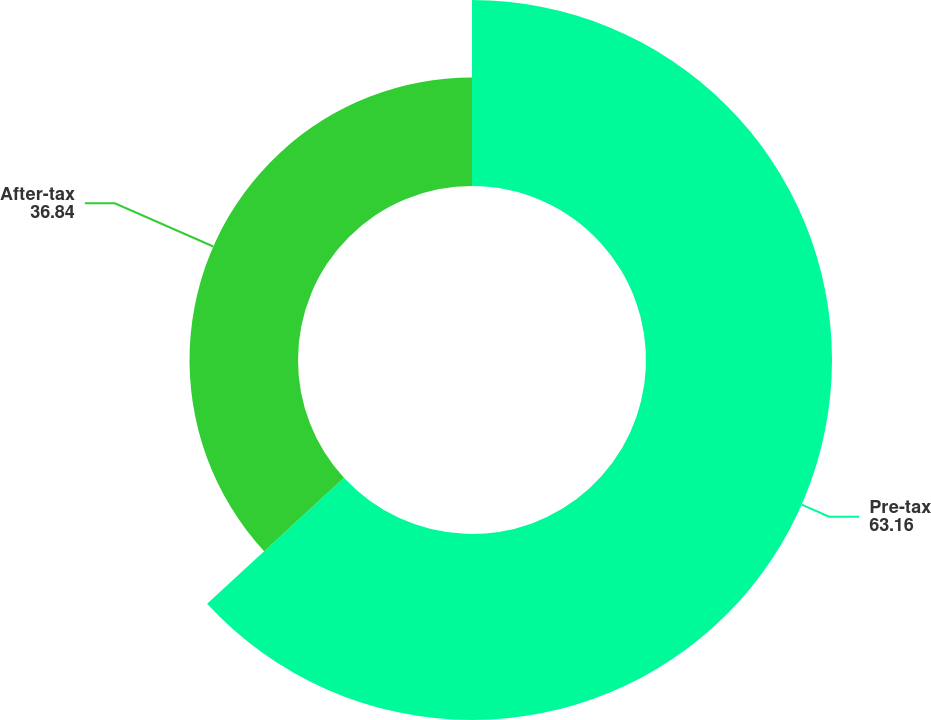Convert chart. <chart><loc_0><loc_0><loc_500><loc_500><pie_chart><fcel>Pre-tax<fcel>After-tax<nl><fcel>63.16%<fcel>36.84%<nl></chart> 